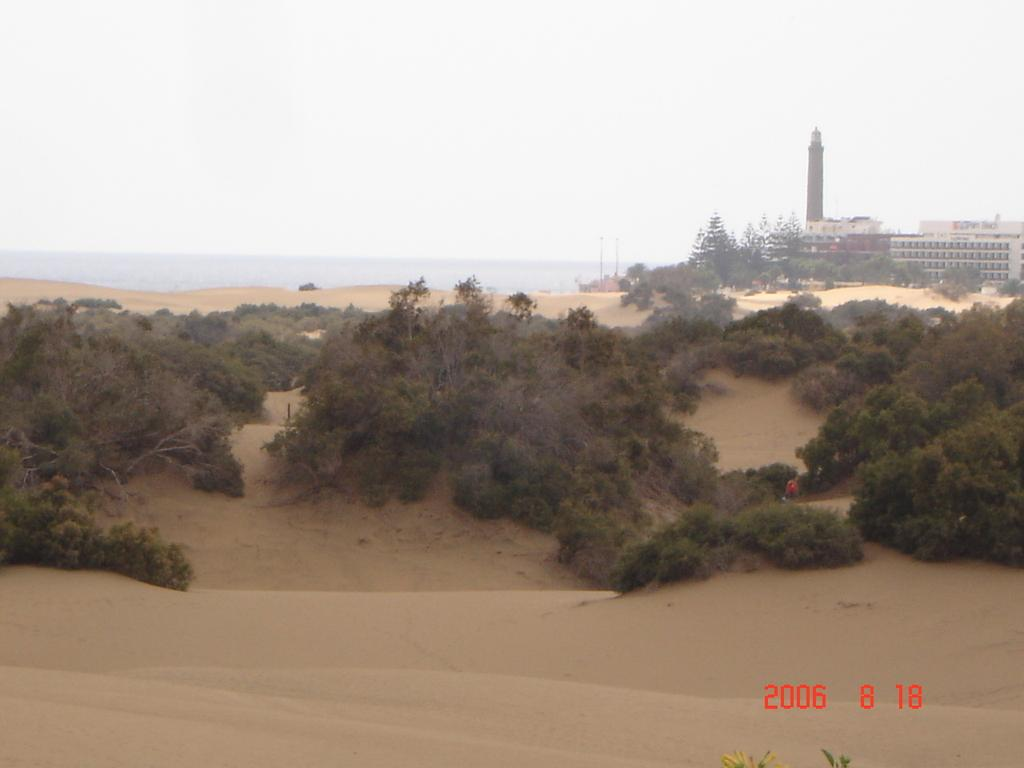What type of natural elements can be seen in the image? There are trees in the image. What type of man-made structures are visible in the background? There are buildings in the background of the image. What part of the natural environment is visible in the image? The sky is visible in the background of the image. Is there any text or marking on the image? Yes, there is a watermark on the bottom right side of the image. What type of oil is being drained from the trees in the image? There is no oil or draining process depicted in the image; it features trees and buildings in the background. 